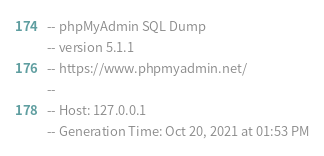<code> <loc_0><loc_0><loc_500><loc_500><_SQL_>-- phpMyAdmin SQL Dump
-- version 5.1.1
-- https://www.phpmyadmin.net/
--
-- Host: 127.0.0.1
-- Generation Time: Oct 20, 2021 at 01:53 PM</code> 